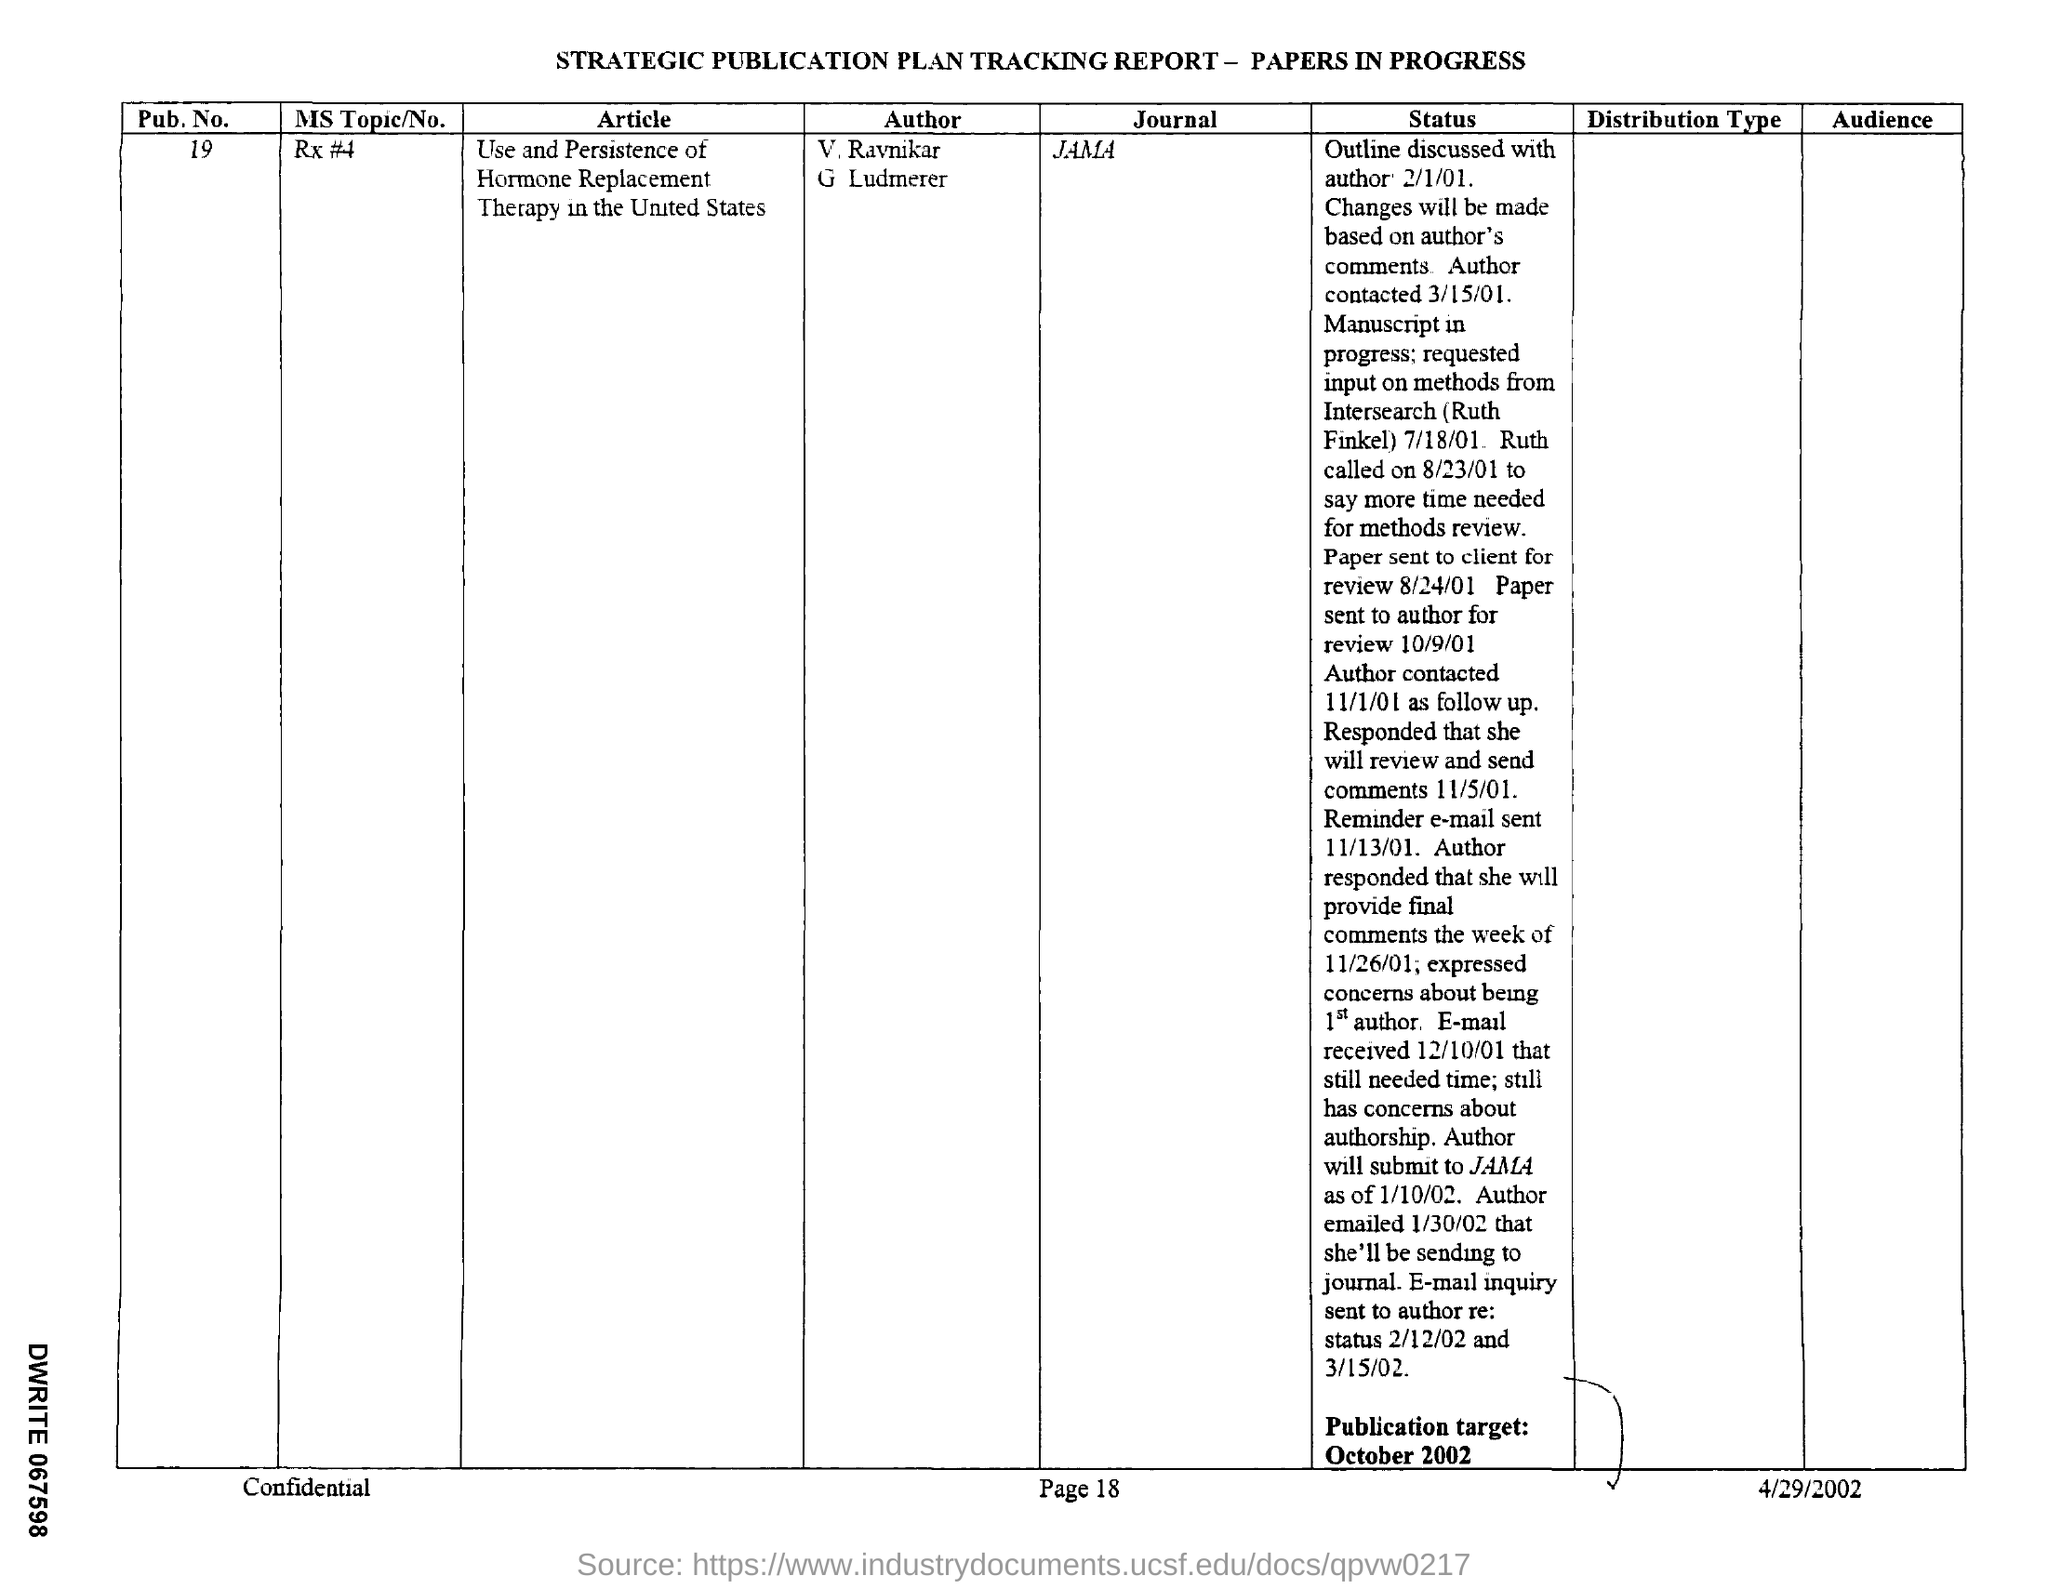What is the pub. no ?
Give a very brief answer. 19. What is the journal name mentioned  ?
Offer a very short reply. Jama. What is the date of the outline discussed with author ?
Offer a terse response. 2/1/01. On which date  the paper sent to author for review ?
Your response must be concise. 10/9/01. On which date the paper was sent to client for review?
Your response must be concise. 8/24/01. On which date author contacted as follow up ?
Your answer should be compact. 11/1/01. On which date the reminder e-mail was sent ?
Offer a terse response. 11/13/01. 